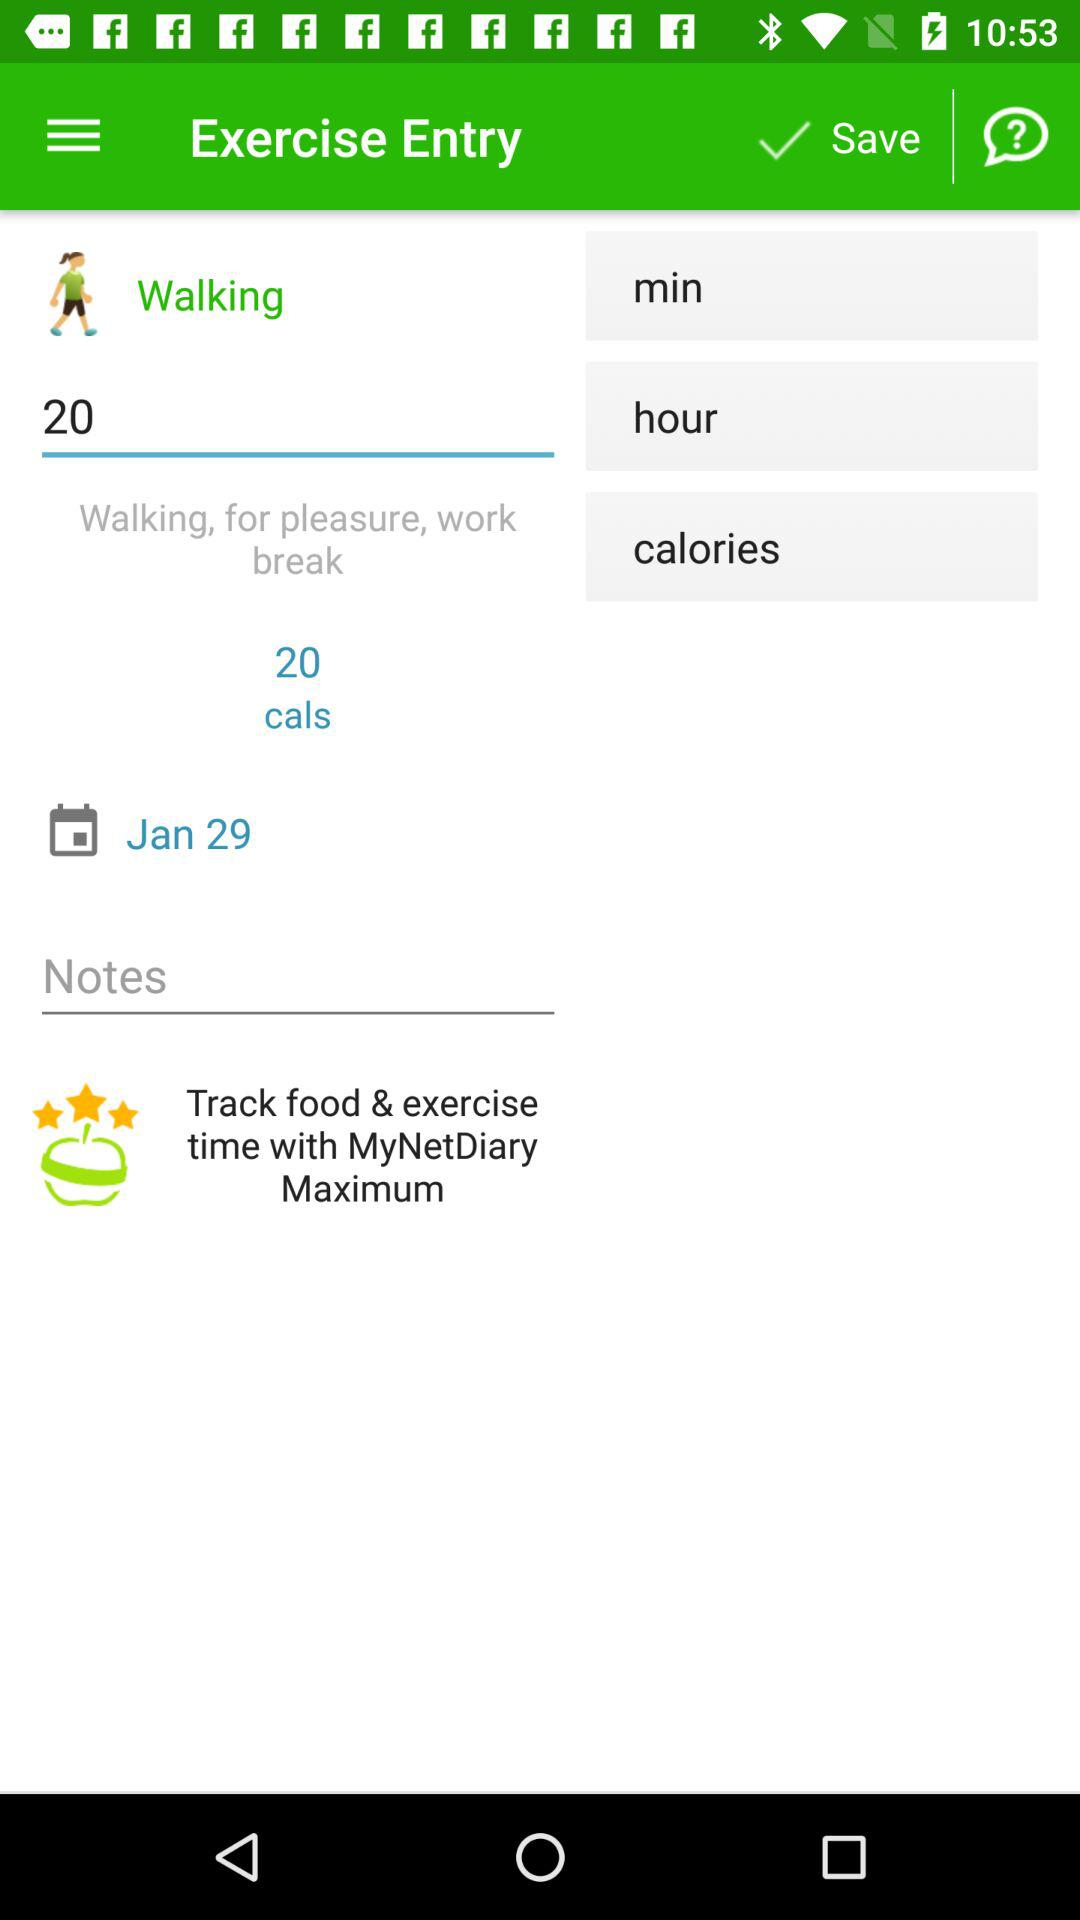What type of exercise is it? The type of exercise is walking. 